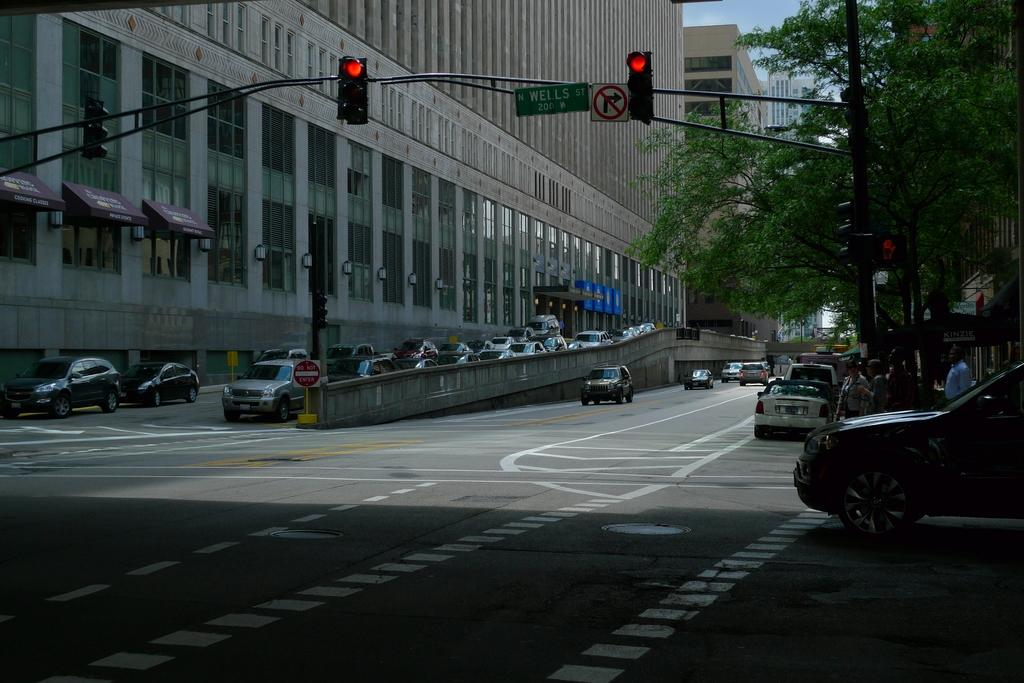<image>
Present a compact description of the photo's key features. a sign that says Wells that is above the street 